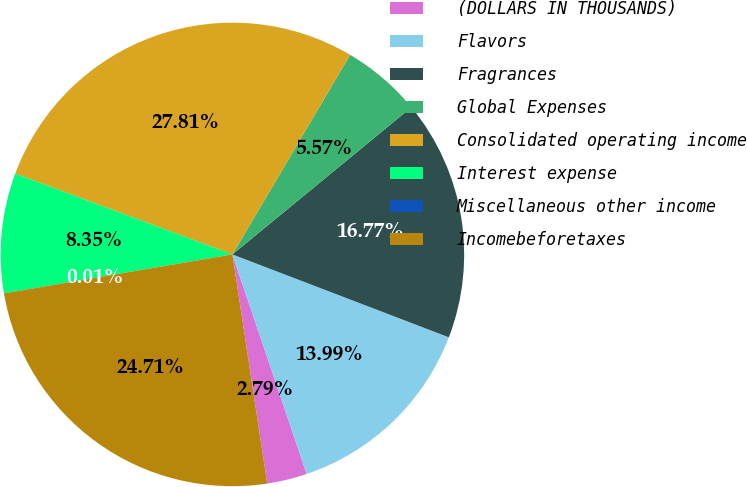<chart> <loc_0><loc_0><loc_500><loc_500><pie_chart><fcel>(DOLLARS IN THOUSANDS)<fcel>Flavors<fcel>Fragrances<fcel>Global Expenses<fcel>Consolidated operating income<fcel>Interest expense<fcel>Miscellaneous other income<fcel>Incomebeforetaxes<nl><fcel>2.79%<fcel>13.99%<fcel>16.77%<fcel>5.57%<fcel>27.81%<fcel>8.35%<fcel>0.01%<fcel>24.71%<nl></chart> 